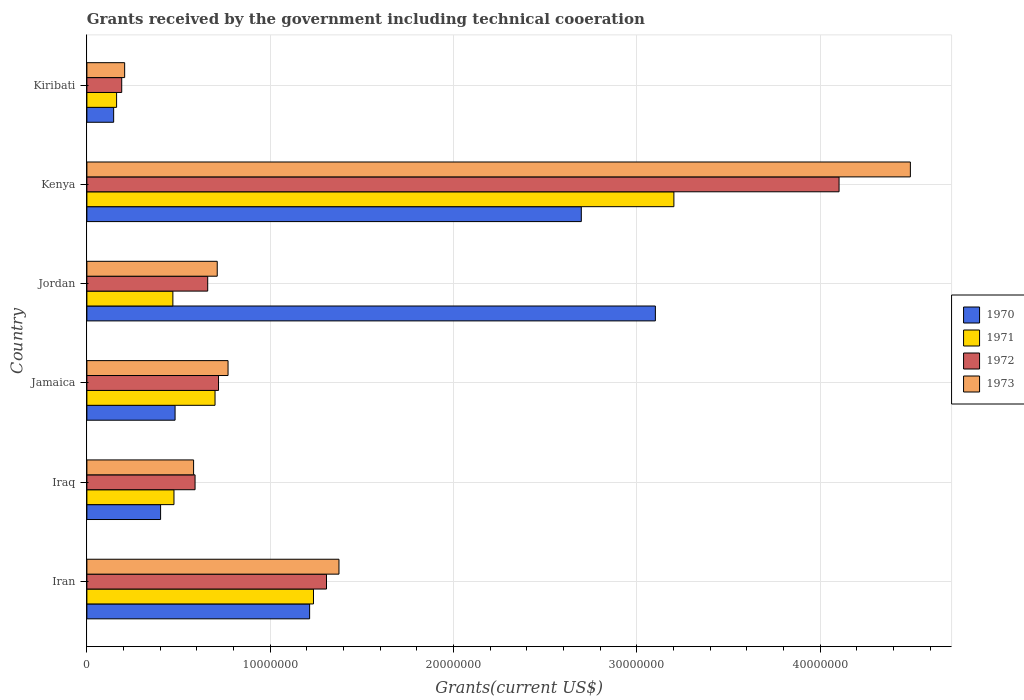How many bars are there on the 2nd tick from the top?
Offer a terse response. 4. How many bars are there on the 5th tick from the bottom?
Provide a short and direct response. 4. What is the label of the 2nd group of bars from the top?
Your answer should be compact. Kenya. What is the total grants received by the government in 1971 in Kiribati?
Your answer should be compact. 1.62e+06. Across all countries, what is the maximum total grants received by the government in 1972?
Your answer should be very brief. 4.10e+07. Across all countries, what is the minimum total grants received by the government in 1971?
Provide a succinct answer. 1.62e+06. In which country was the total grants received by the government in 1971 maximum?
Offer a very short reply. Kenya. In which country was the total grants received by the government in 1973 minimum?
Provide a short and direct response. Kiribati. What is the total total grants received by the government in 1971 in the graph?
Your answer should be very brief. 6.24e+07. What is the difference between the total grants received by the government in 1972 in Iran and that in Iraq?
Offer a very short reply. 7.17e+06. What is the difference between the total grants received by the government in 1972 in Jamaica and the total grants received by the government in 1973 in Kenya?
Ensure brevity in your answer.  -3.77e+07. What is the average total grants received by the government in 1970 per country?
Keep it short and to the point. 1.34e+07. What is the difference between the total grants received by the government in 1970 and total grants received by the government in 1973 in Iraq?
Provide a short and direct response. -1.80e+06. What is the ratio of the total grants received by the government in 1972 in Iran to that in Kiribati?
Keep it short and to the point. 6.88. Is the total grants received by the government in 1973 in Jamaica less than that in Kenya?
Give a very brief answer. Yes. What is the difference between the highest and the second highest total grants received by the government in 1971?
Your answer should be compact. 1.97e+07. What is the difference between the highest and the lowest total grants received by the government in 1971?
Ensure brevity in your answer.  3.04e+07. In how many countries, is the total grants received by the government in 1970 greater than the average total grants received by the government in 1970 taken over all countries?
Your answer should be compact. 2. Is the sum of the total grants received by the government in 1972 in Kenya and Kiribati greater than the maximum total grants received by the government in 1971 across all countries?
Ensure brevity in your answer.  Yes. What does the 4th bar from the top in Jamaica represents?
Your answer should be compact. 1970. What does the 2nd bar from the bottom in Kenya represents?
Your response must be concise. 1971. Is it the case that in every country, the sum of the total grants received by the government in 1971 and total grants received by the government in 1970 is greater than the total grants received by the government in 1972?
Give a very brief answer. Yes. How many countries are there in the graph?
Ensure brevity in your answer.  6. What is the difference between two consecutive major ticks on the X-axis?
Provide a succinct answer. 1.00e+07. Are the values on the major ticks of X-axis written in scientific E-notation?
Make the answer very short. No. Does the graph contain grids?
Your response must be concise. Yes. How many legend labels are there?
Keep it short and to the point. 4. How are the legend labels stacked?
Give a very brief answer. Vertical. What is the title of the graph?
Ensure brevity in your answer.  Grants received by the government including technical cooeration. What is the label or title of the X-axis?
Make the answer very short. Grants(current US$). What is the Grants(current US$) in 1970 in Iran?
Offer a terse response. 1.22e+07. What is the Grants(current US$) of 1971 in Iran?
Provide a short and direct response. 1.24e+07. What is the Grants(current US$) in 1972 in Iran?
Provide a succinct answer. 1.31e+07. What is the Grants(current US$) of 1973 in Iran?
Make the answer very short. 1.38e+07. What is the Grants(current US$) of 1970 in Iraq?
Your answer should be very brief. 4.02e+06. What is the Grants(current US$) of 1971 in Iraq?
Provide a short and direct response. 4.75e+06. What is the Grants(current US$) in 1972 in Iraq?
Offer a very short reply. 5.90e+06. What is the Grants(current US$) in 1973 in Iraq?
Offer a terse response. 5.82e+06. What is the Grants(current US$) of 1970 in Jamaica?
Offer a very short reply. 4.81e+06. What is the Grants(current US$) of 1971 in Jamaica?
Ensure brevity in your answer.  6.99e+06. What is the Grants(current US$) of 1972 in Jamaica?
Offer a very short reply. 7.18e+06. What is the Grants(current US$) in 1973 in Jamaica?
Keep it short and to the point. 7.70e+06. What is the Grants(current US$) in 1970 in Jordan?
Ensure brevity in your answer.  3.10e+07. What is the Grants(current US$) in 1971 in Jordan?
Offer a very short reply. 4.69e+06. What is the Grants(current US$) of 1972 in Jordan?
Keep it short and to the point. 6.59e+06. What is the Grants(current US$) in 1973 in Jordan?
Ensure brevity in your answer.  7.11e+06. What is the Grants(current US$) of 1970 in Kenya?
Provide a succinct answer. 2.70e+07. What is the Grants(current US$) of 1971 in Kenya?
Your answer should be very brief. 3.20e+07. What is the Grants(current US$) of 1972 in Kenya?
Provide a short and direct response. 4.10e+07. What is the Grants(current US$) in 1973 in Kenya?
Your answer should be very brief. 4.49e+07. What is the Grants(current US$) in 1970 in Kiribati?
Your answer should be compact. 1.46e+06. What is the Grants(current US$) of 1971 in Kiribati?
Make the answer very short. 1.62e+06. What is the Grants(current US$) of 1972 in Kiribati?
Provide a succinct answer. 1.90e+06. What is the Grants(current US$) in 1973 in Kiribati?
Your response must be concise. 2.06e+06. Across all countries, what is the maximum Grants(current US$) in 1970?
Your answer should be compact. 3.10e+07. Across all countries, what is the maximum Grants(current US$) of 1971?
Provide a short and direct response. 3.20e+07. Across all countries, what is the maximum Grants(current US$) in 1972?
Provide a succinct answer. 4.10e+07. Across all countries, what is the maximum Grants(current US$) of 1973?
Your answer should be very brief. 4.49e+07. Across all countries, what is the minimum Grants(current US$) of 1970?
Your answer should be compact. 1.46e+06. Across all countries, what is the minimum Grants(current US$) of 1971?
Ensure brevity in your answer.  1.62e+06. Across all countries, what is the minimum Grants(current US$) of 1972?
Give a very brief answer. 1.90e+06. Across all countries, what is the minimum Grants(current US$) of 1973?
Give a very brief answer. 2.06e+06. What is the total Grants(current US$) in 1970 in the graph?
Your response must be concise. 8.04e+07. What is the total Grants(current US$) of 1971 in the graph?
Your answer should be very brief. 6.24e+07. What is the total Grants(current US$) of 1972 in the graph?
Keep it short and to the point. 7.57e+07. What is the total Grants(current US$) of 1973 in the graph?
Provide a succinct answer. 8.14e+07. What is the difference between the Grants(current US$) in 1970 in Iran and that in Iraq?
Your response must be concise. 8.13e+06. What is the difference between the Grants(current US$) in 1971 in Iran and that in Iraq?
Make the answer very short. 7.61e+06. What is the difference between the Grants(current US$) in 1972 in Iran and that in Iraq?
Offer a very short reply. 7.17e+06. What is the difference between the Grants(current US$) in 1973 in Iran and that in Iraq?
Offer a very short reply. 7.93e+06. What is the difference between the Grants(current US$) of 1970 in Iran and that in Jamaica?
Ensure brevity in your answer.  7.34e+06. What is the difference between the Grants(current US$) in 1971 in Iran and that in Jamaica?
Ensure brevity in your answer.  5.37e+06. What is the difference between the Grants(current US$) of 1972 in Iran and that in Jamaica?
Ensure brevity in your answer.  5.89e+06. What is the difference between the Grants(current US$) in 1973 in Iran and that in Jamaica?
Your answer should be very brief. 6.05e+06. What is the difference between the Grants(current US$) of 1970 in Iran and that in Jordan?
Offer a very short reply. -1.89e+07. What is the difference between the Grants(current US$) of 1971 in Iran and that in Jordan?
Offer a very short reply. 7.67e+06. What is the difference between the Grants(current US$) of 1972 in Iran and that in Jordan?
Provide a short and direct response. 6.48e+06. What is the difference between the Grants(current US$) in 1973 in Iran and that in Jordan?
Give a very brief answer. 6.64e+06. What is the difference between the Grants(current US$) of 1970 in Iran and that in Kenya?
Provide a succinct answer. -1.48e+07. What is the difference between the Grants(current US$) in 1971 in Iran and that in Kenya?
Your answer should be compact. -1.97e+07. What is the difference between the Grants(current US$) in 1972 in Iran and that in Kenya?
Provide a short and direct response. -2.80e+07. What is the difference between the Grants(current US$) of 1973 in Iran and that in Kenya?
Make the answer very short. -3.12e+07. What is the difference between the Grants(current US$) of 1970 in Iran and that in Kiribati?
Keep it short and to the point. 1.07e+07. What is the difference between the Grants(current US$) of 1971 in Iran and that in Kiribati?
Offer a very short reply. 1.07e+07. What is the difference between the Grants(current US$) of 1972 in Iran and that in Kiribati?
Provide a succinct answer. 1.12e+07. What is the difference between the Grants(current US$) in 1973 in Iran and that in Kiribati?
Keep it short and to the point. 1.17e+07. What is the difference between the Grants(current US$) of 1970 in Iraq and that in Jamaica?
Keep it short and to the point. -7.90e+05. What is the difference between the Grants(current US$) in 1971 in Iraq and that in Jamaica?
Provide a short and direct response. -2.24e+06. What is the difference between the Grants(current US$) of 1972 in Iraq and that in Jamaica?
Your answer should be very brief. -1.28e+06. What is the difference between the Grants(current US$) in 1973 in Iraq and that in Jamaica?
Provide a short and direct response. -1.88e+06. What is the difference between the Grants(current US$) of 1970 in Iraq and that in Jordan?
Your response must be concise. -2.70e+07. What is the difference between the Grants(current US$) in 1972 in Iraq and that in Jordan?
Your answer should be compact. -6.90e+05. What is the difference between the Grants(current US$) in 1973 in Iraq and that in Jordan?
Your answer should be compact. -1.29e+06. What is the difference between the Grants(current US$) of 1970 in Iraq and that in Kenya?
Your response must be concise. -2.30e+07. What is the difference between the Grants(current US$) in 1971 in Iraq and that in Kenya?
Provide a succinct answer. -2.73e+07. What is the difference between the Grants(current US$) in 1972 in Iraq and that in Kenya?
Provide a succinct answer. -3.51e+07. What is the difference between the Grants(current US$) of 1973 in Iraq and that in Kenya?
Provide a succinct answer. -3.91e+07. What is the difference between the Grants(current US$) in 1970 in Iraq and that in Kiribati?
Give a very brief answer. 2.56e+06. What is the difference between the Grants(current US$) of 1971 in Iraq and that in Kiribati?
Ensure brevity in your answer.  3.13e+06. What is the difference between the Grants(current US$) of 1972 in Iraq and that in Kiribati?
Your response must be concise. 4.00e+06. What is the difference between the Grants(current US$) of 1973 in Iraq and that in Kiribati?
Keep it short and to the point. 3.76e+06. What is the difference between the Grants(current US$) in 1970 in Jamaica and that in Jordan?
Keep it short and to the point. -2.62e+07. What is the difference between the Grants(current US$) in 1971 in Jamaica and that in Jordan?
Make the answer very short. 2.30e+06. What is the difference between the Grants(current US$) of 1972 in Jamaica and that in Jordan?
Give a very brief answer. 5.90e+05. What is the difference between the Grants(current US$) in 1973 in Jamaica and that in Jordan?
Ensure brevity in your answer.  5.90e+05. What is the difference between the Grants(current US$) in 1970 in Jamaica and that in Kenya?
Keep it short and to the point. -2.22e+07. What is the difference between the Grants(current US$) of 1971 in Jamaica and that in Kenya?
Make the answer very short. -2.50e+07. What is the difference between the Grants(current US$) of 1972 in Jamaica and that in Kenya?
Your answer should be compact. -3.38e+07. What is the difference between the Grants(current US$) of 1973 in Jamaica and that in Kenya?
Provide a short and direct response. -3.72e+07. What is the difference between the Grants(current US$) of 1970 in Jamaica and that in Kiribati?
Your response must be concise. 3.35e+06. What is the difference between the Grants(current US$) of 1971 in Jamaica and that in Kiribati?
Offer a very short reply. 5.37e+06. What is the difference between the Grants(current US$) of 1972 in Jamaica and that in Kiribati?
Your answer should be compact. 5.28e+06. What is the difference between the Grants(current US$) in 1973 in Jamaica and that in Kiribati?
Provide a succinct answer. 5.64e+06. What is the difference between the Grants(current US$) in 1970 in Jordan and that in Kenya?
Offer a terse response. 4.04e+06. What is the difference between the Grants(current US$) of 1971 in Jordan and that in Kenya?
Offer a terse response. -2.73e+07. What is the difference between the Grants(current US$) of 1972 in Jordan and that in Kenya?
Give a very brief answer. -3.44e+07. What is the difference between the Grants(current US$) of 1973 in Jordan and that in Kenya?
Offer a terse response. -3.78e+07. What is the difference between the Grants(current US$) in 1970 in Jordan and that in Kiribati?
Your answer should be compact. 2.96e+07. What is the difference between the Grants(current US$) in 1971 in Jordan and that in Kiribati?
Keep it short and to the point. 3.07e+06. What is the difference between the Grants(current US$) in 1972 in Jordan and that in Kiribati?
Give a very brief answer. 4.69e+06. What is the difference between the Grants(current US$) in 1973 in Jordan and that in Kiribati?
Provide a succinct answer. 5.05e+06. What is the difference between the Grants(current US$) of 1970 in Kenya and that in Kiribati?
Your answer should be very brief. 2.55e+07. What is the difference between the Grants(current US$) of 1971 in Kenya and that in Kiribati?
Offer a very short reply. 3.04e+07. What is the difference between the Grants(current US$) in 1972 in Kenya and that in Kiribati?
Provide a short and direct response. 3.91e+07. What is the difference between the Grants(current US$) in 1973 in Kenya and that in Kiribati?
Ensure brevity in your answer.  4.29e+07. What is the difference between the Grants(current US$) in 1970 in Iran and the Grants(current US$) in 1971 in Iraq?
Give a very brief answer. 7.40e+06. What is the difference between the Grants(current US$) of 1970 in Iran and the Grants(current US$) of 1972 in Iraq?
Offer a terse response. 6.25e+06. What is the difference between the Grants(current US$) of 1970 in Iran and the Grants(current US$) of 1973 in Iraq?
Provide a short and direct response. 6.33e+06. What is the difference between the Grants(current US$) of 1971 in Iran and the Grants(current US$) of 1972 in Iraq?
Provide a succinct answer. 6.46e+06. What is the difference between the Grants(current US$) in 1971 in Iran and the Grants(current US$) in 1973 in Iraq?
Give a very brief answer. 6.54e+06. What is the difference between the Grants(current US$) in 1972 in Iran and the Grants(current US$) in 1973 in Iraq?
Your response must be concise. 7.25e+06. What is the difference between the Grants(current US$) in 1970 in Iran and the Grants(current US$) in 1971 in Jamaica?
Make the answer very short. 5.16e+06. What is the difference between the Grants(current US$) in 1970 in Iran and the Grants(current US$) in 1972 in Jamaica?
Offer a terse response. 4.97e+06. What is the difference between the Grants(current US$) of 1970 in Iran and the Grants(current US$) of 1973 in Jamaica?
Your answer should be compact. 4.45e+06. What is the difference between the Grants(current US$) of 1971 in Iran and the Grants(current US$) of 1972 in Jamaica?
Offer a very short reply. 5.18e+06. What is the difference between the Grants(current US$) in 1971 in Iran and the Grants(current US$) in 1973 in Jamaica?
Your answer should be very brief. 4.66e+06. What is the difference between the Grants(current US$) of 1972 in Iran and the Grants(current US$) of 1973 in Jamaica?
Provide a short and direct response. 5.37e+06. What is the difference between the Grants(current US$) of 1970 in Iran and the Grants(current US$) of 1971 in Jordan?
Ensure brevity in your answer.  7.46e+06. What is the difference between the Grants(current US$) in 1970 in Iran and the Grants(current US$) in 1972 in Jordan?
Keep it short and to the point. 5.56e+06. What is the difference between the Grants(current US$) in 1970 in Iran and the Grants(current US$) in 1973 in Jordan?
Make the answer very short. 5.04e+06. What is the difference between the Grants(current US$) in 1971 in Iran and the Grants(current US$) in 1972 in Jordan?
Keep it short and to the point. 5.77e+06. What is the difference between the Grants(current US$) of 1971 in Iran and the Grants(current US$) of 1973 in Jordan?
Ensure brevity in your answer.  5.25e+06. What is the difference between the Grants(current US$) of 1972 in Iran and the Grants(current US$) of 1973 in Jordan?
Ensure brevity in your answer.  5.96e+06. What is the difference between the Grants(current US$) in 1970 in Iran and the Grants(current US$) in 1971 in Kenya?
Make the answer very short. -1.99e+07. What is the difference between the Grants(current US$) in 1970 in Iran and the Grants(current US$) in 1972 in Kenya?
Give a very brief answer. -2.89e+07. What is the difference between the Grants(current US$) in 1970 in Iran and the Grants(current US$) in 1973 in Kenya?
Offer a very short reply. -3.28e+07. What is the difference between the Grants(current US$) of 1971 in Iran and the Grants(current US$) of 1972 in Kenya?
Keep it short and to the point. -2.87e+07. What is the difference between the Grants(current US$) in 1971 in Iran and the Grants(current US$) in 1973 in Kenya?
Your response must be concise. -3.26e+07. What is the difference between the Grants(current US$) of 1972 in Iran and the Grants(current US$) of 1973 in Kenya?
Provide a short and direct response. -3.18e+07. What is the difference between the Grants(current US$) in 1970 in Iran and the Grants(current US$) in 1971 in Kiribati?
Give a very brief answer. 1.05e+07. What is the difference between the Grants(current US$) of 1970 in Iran and the Grants(current US$) of 1972 in Kiribati?
Offer a very short reply. 1.02e+07. What is the difference between the Grants(current US$) in 1970 in Iran and the Grants(current US$) in 1973 in Kiribati?
Provide a short and direct response. 1.01e+07. What is the difference between the Grants(current US$) of 1971 in Iran and the Grants(current US$) of 1972 in Kiribati?
Your response must be concise. 1.05e+07. What is the difference between the Grants(current US$) of 1971 in Iran and the Grants(current US$) of 1973 in Kiribati?
Give a very brief answer. 1.03e+07. What is the difference between the Grants(current US$) of 1972 in Iran and the Grants(current US$) of 1973 in Kiribati?
Give a very brief answer. 1.10e+07. What is the difference between the Grants(current US$) of 1970 in Iraq and the Grants(current US$) of 1971 in Jamaica?
Provide a short and direct response. -2.97e+06. What is the difference between the Grants(current US$) of 1970 in Iraq and the Grants(current US$) of 1972 in Jamaica?
Make the answer very short. -3.16e+06. What is the difference between the Grants(current US$) in 1970 in Iraq and the Grants(current US$) in 1973 in Jamaica?
Offer a terse response. -3.68e+06. What is the difference between the Grants(current US$) in 1971 in Iraq and the Grants(current US$) in 1972 in Jamaica?
Offer a terse response. -2.43e+06. What is the difference between the Grants(current US$) in 1971 in Iraq and the Grants(current US$) in 1973 in Jamaica?
Make the answer very short. -2.95e+06. What is the difference between the Grants(current US$) of 1972 in Iraq and the Grants(current US$) of 1973 in Jamaica?
Your answer should be very brief. -1.80e+06. What is the difference between the Grants(current US$) of 1970 in Iraq and the Grants(current US$) of 1971 in Jordan?
Make the answer very short. -6.70e+05. What is the difference between the Grants(current US$) of 1970 in Iraq and the Grants(current US$) of 1972 in Jordan?
Your answer should be compact. -2.57e+06. What is the difference between the Grants(current US$) in 1970 in Iraq and the Grants(current US$) in 1973 in Jordan?
Ensure brevity in your answer.  -3.09e+06. What is the difference between the Grants(current US$) in 1971 in Iraq and the Grants(current US$) in 1972 in Jordan?
Offer a terse response. -1.84e+06. What is the difference between the Grants(current US$) of 1971 in Iraq and the Grants(current US$) of 1973 in Jordan?
Ensure brevity in your answer.  -2.36e+06. What is the difference between the Grants(current US$) of 1972 in Iraq and the Grants(current US$) of 1973 in Jordan?
Keep it short and to the point. -1.21e+06. What is the difference between the Grants(current US$) in 1970 in Iraq and the Grants(current US$) in 1971 in Kenya?
Provide a short and direct response. -2.80e+07. What is the difference between the Grants(current US$) of 1970 in Iraq and the Grants(current US$) of 1972 in Kenya?
Ensure brevity in your answer.  -3.70e+07. What is the difference between the Grants(current US$) of 1970 in Iraq and the Grants(current US$) of 1973 in Kenya?
Give a very brief answer. -4.09e+07. What is the difference between the Grants(current US$) of 1971 in Iraq and the Grants(current US$) of 1972 in Kenya?
Your response must be concise. -3.63e+07. What is the difference between the Grants(current US$) in 1971 in Iraq and the Grants(current US$) in 1973 in Kenya?
Ensure brevity in your answer.  -4.02e+07. What is the difference between the Grants(current US$) of 1972 in Iraq and the Grants(current US$) of 1973 in Kenya?
Make the answer very short. -3.90e+07. What is the difference between the Grants(current US$) of 1970 in Iraq and the Grants(current US$) of 1971 in Kiribati?
Keep it short and to the point. 2.40e+06. What is the difference between the Grants(current US$) of 1970 in Iraq and the Grants(current US$) of 1972 in Kiribati?
Provide a short and direct response. 2.12e+06. What is the difference between the Grants(current US$) of 1970 in Iraq and the Grants(current US$) of 1973 in Kiribati?
Ensure brevity in your answer.  1.96e+06. What is the difference between the Grants(current US$) of 1971 in Iraq and the Grants(current US$) of 1972 in Kiribati?
Make the answer very short. 2.85e+06. What is the difference between the Grants(current US$) of 1971 in Iraq and the Grants(current US$) of 1973 in Kiribati?
Provide a short and direct response. 2.69e+06. What is the difference between the Grants(current US$) in 1972 in Iraq and the Grants(current US$) in 1973 in Kiribati?
Your answer should be compact. 3.84e+06. What is the difference between the Grants(current US$) in 1970 in Jamaica and the Grants(current US$) in 1972 in Jordan?
Your response must be concise. -1.78e+06. What is the difference between the Grants(current US$) in 1970 in Jamaica and the Grants(current US$) in 1973 in Jordan?
Provide a short and direct response. -2.30e+06. What is the difference between the Grants(current US$) in 1971 in Jamaica and the Grants(current US$) in 1972 in Jordan?
Your answer should be very brief. 4.00e+05. What is the difference between the Grants(current US$) of 1970 in Jamaica and the Grants(current US$) of 1971 in Kenya?
Your answer should be compact. -2.72e+07. What is the difference between the Grants(current US$) in 1970 in Jamaica and the Grants(current US$) in 1972 in Kenya?
Your answer should be compact. -3.62e+07. What is the difference between the Grants(current US$) in 1970 in Jamaica and the Grants(current US$) in 1973 in Kenya?
Offer a very short reply. -4.01e+07. What is the difference between the Grants(current US$) of 1971 in Jamaica and the Grants(current US$) of 1972 in Kenya?
Your answer should be compact. -3.40e+07. What is the difference between the Grants(current US$) of 1971 in Jamaica and the Grants(current US$) of 1973 in Kenya?
Offer a very short reply. -3.79e+07. What is the difference between the Grants(current US$) in 1972 in Jamaica and the Grants(current US$) in 1973 in Kenya?
Your answer should be very brief. -3.77e+07. What is the difference between the Grants(current US$) of 1970 in Jamaica and the Grants(current US$) of 1971 in Kiribati?
Provide a short and direct response. 3.19e+06. What is the difference between the Grants(current US$) of 1970 in Jamaica and the Grants(current US$) of 1972 in Kiribati?
Ensure brevity in your answer.  2.91e+06. What is the difference between the Grants(current US$) in 1970 in Jamaica and the Grants(current US$) in 1973 in Kiribati?
Provide a short and direct response. 2.75e+06. What is the difference between the Grants(current US$) in 1971 in Jamaica and the Grants(current US$) in 1972 in Kiribati?
Provide a short and direct response. 5.09e+06. What is the difference between the Grants(current US$) of 1971 in Jamaica and the Grants(current US$) of 1973 in Kiribati?
Your response must be concise. 4.93e+06. What is the difference between the Grants(current US$) of 1972 in Jamaica and the Grants(current US$) of 1973 in Kiribati?
Keep it short and to the point. 5.12e+06. What is the difference between the Grants(current US$) of 1970 in Jordan and the Grants(current US$) of 1971 in Kenya?
Give a very brief answer. -1.01e+06. What is the difference between the Grants(current US$) of 1970 in Jordan and the Grants(current US$) of 1972 in Kenya?
Offer a terse response. -1.00e+07. What is the difference between the Grants(current US$) of 1970 in Jordan and the Grants(current US$) of 1973 in Kenya?
Your answer should be very brief. -1.39e+07. What is the difference between the Grants(current US$) of 1971 in Jordan and the Grants(current US$) of 1972 in Kenya?
Offer a very short reply. -3.63e+07. What is the difference between the Grants(current US$) in 1971 in Jordan and the Grants(current US$) in 1973 in Kenya?
Provide a succinct answer. -4.02e+07. What is the difference between the Grants(current US$) in 1972 in Jordan and the Grants(current US$) in 1973 in Kenya?
Give a very brief answer. -3.83e+07. What is the difference between the Grants(current US$) of 1970 in Jordan and the Grants(current US$) of 1971 in Kiribati?
Your response must be concise. 2.94e+07. What is the difference between the Grants(current US$) in 1970 in Jordan and the Grants(current US$) in 1972 in Kiribati?
Offer a very short reply. 2.91e+07. What is the difference between the Grants(current US$) of 1970 in Jordan and the Grants(current US$) of 1973 in Kiribati?
Provide a succinct answer. 2.90e+07. What is the difference between the Grants(current US$) in 1971 in Jordan and the Grants(current US$) in 1972 in Kiribati?
Your answer should be very brief. 2.79e+06. What is the difference between the Grants(current US$) of 1971 in Jordan and the Grants(current US$) of 1973 in Kiribati?
Offer a terse response. 2.63e+06. What is the difference between the Grants(current US$) in 1972 in Jordan and the Grants(current US$) in 1973 in Kiribati?
Your answer should be very brief. 4.53e+06. What is the difference between the Grants(current US$) in 1970 in Kenya and the Grants(current US$) in 1971 in Kiribati?
Keep it short and to the point. 2.54e+07. What is the difference between the Grants(current US$) of 1970 in Kenya and the Grants(current US$) of 1972 in Kiribati?
Provide a short and direct response. 2.51e+07. What is the difference between the Grants(current US$) of 1970 in Kenya and the Grants(current US$) of 1973 in Kiribati?
Your answer should be compact. 2.49e+07. What is the difference between the Grants(current US$) in 1971 in Kenya and the Grants(current US$) in 1972 in Kiribati?
Keep it short and to the point. 3.01e+07. What is the difference between the Grants(current US$) in 1971 in Kenya and the Grants(current US$) in 1973 in Kiribati?
Provide a succinct answer. 3.00e+07. What is the difference between the Grants(current US$) of 1972 in Kenya and the Grants(current US$) of 1973 in Kiribati?
Offer a terse response. 3.90e+07. What is the average Grants(current US$) in 1970 per country?
Offer a terse response. 1.34e+07. What is the average Grants(current US$) in 1971 per country?
Offer a very short reply. 1.04e+07. What is the average Grants(current US$) in 1972 per country?
Make the answer very short. 1.26e+07. What is the average Grants(current US$) in 1973 per country?
Give a very brief answer. 1.36e+07. What is the difference between the Grants(current US$) in 1970 and Grants(current US$) in 1971 in Iran?
Your answer should be very brief. -2.10e+05. What is the difference between the Grants(current US$) of 1970 and Grants(current US$) of 1972 in Iran?
Provide a short and direct response. -9.20e+05. What is the difference between the Grants(current US$) in 1970 and Grants(current US$) in 1973 in Iran?
Your response must be concise. -1.60e+06. What is the difference between the Grants(current US$) in 1971 and Grants(current US$) in 1972 in Iran?
Offer a terse response. -7.10e+05. What is the difference between the Grants(current US$) in 1971 and Grants(current US$) in 1973 in Iran?
Keep it short and to the point. -1.39e+06. What is the difference between the Grants(current US$) of 1972 and Grants(current US$) of 1973 in Iran?
Provide a short and direct response. -6.80e+05. What is the difference between the Grants(current US$) of 1970 and Grants(current US$) of 1971 in Iraq?
Keep it short and to the point. -7.30e+05. What is the difference between the Grants(current US$) of 1970 and Grants(current US$) of 1972 in Iraq?
Make the answer very short. -1.88e+06. What is the difference between the Grants(current US$) of 1970 and Grants(current US$) of 1973 in Iraq?
Keep it short and to the point. -1.80e+06. What is the difference between the Grants(current US$) of 1971 and Grants(current US$) of 1972 in Iraq?
Offer a very short reply. -1.15e+06. What is the difference between the Grants(current US$) of 1971 and Grants(current US$) of 1973 in Iraq?
Provide a short and direct response. -1.07e+06. What is the difference between the Grants(current US$) in 1972 and Grants(current US$) in 1973 in Iraq?
Make the answer very short. 8.00e+04. What is the difference between the Grants(current US$) in 1970 and Grants(current US$) in 1971 in Jamaica?
Your answer should be very brief. -2.18e+06. What is the difference between the Grants(current US$) of 1970 and Grants(current US$) of 1972 in Jamaica?
Ensure brevity in your answer.  -2.37e+06. What is the difference between the Grants(current US$) in 1970 and Grants(current US$) in 1973 in Jamaica?
Give a very brief answer. -2.89e+06. What is the difference between the Grants(current US$) in 1971 and Grants(current US$) in 1973 in Jamaica?
Your answer should be compact. -7.10e+05. What is the difference between the Grants(current US$) of 1972 and Grants(current US$) of 1973 in Jamaica?
Ensure brevity in your answer.  -5.20e+05. What is the difference between the Grants(current US$) in 1970 and Grants(current US$) in 1971 in Jordan?
Keep it short and to the point. 2.63e+07. What is the difference between the Grants(current US$) in 1970 and Grants(current US$) in 1972 in Jordan?
Make the answer very short. 2.44e+07. What is the difference between the Grants(current US$) in 1970 and Grants(current US$) in 1973 in Jordan?
Make the answer very short. 2.39e+07. What is the difference between the Grants(current US$) in 1971 and Grants(current US$) in 1972 in Jordan?
Make the answer very short. -1.90e+06. What is the difference between the Grants(current US$) in 1971 and Grants(current US$) in 1973 in Jordan?
Keep it short and to the point. -2.42e+06. What is the difference between the Grants(current US$) in 1972 and Grants(current US$) in 1973 in Jordan?
Your answer should be compact. -5.20e+05. What is the difference between the Grants(current US$) in 1970 and Grants(current US$) in 1971 in Kenya?
Your answer should be very brief. -5.05e+06. What is the difference between the Grants(current US$) of 1970 and Grants(current US$) of 1972 in Kenya?
Provide a succinct answer. -1.41e+07. What is the difference between the Grants(current US$) of 1970 and Grants(current US$) of 1973 in Kenya?
Offer a terse response. -1.80e+07. What is the difference between the Grants(current US$) in 1971 and Grants(current US$) in 1972 in Kenya?
Provide a short and direct response. -9.01e+06. What is the difference between the Grants(current US$) in 1971 and Grants(current US$) in 1973 in Kenya?
Keep it short and to the point. -1.29e+07. What is the difference between the Grants(current US$) of 1972 and Grants(current US$) of 1973 in Kenya?
Keep it short and to the point. -3.89e+06. What is the difference between the Grants(current US$) of 1970 and Grants(current US$) of 1971 in Kiribati?
Offer a very short reply. -1.60e+05. What is the difference between the Grants(current US$) in 1970 and Grants(current US$) in 1972 in Kiribati?
Provide a short and direct response. -4.40e+05. What is the difference between the Grants(current US$) in 1970 and Grants(current US$) in 1973 in Kiribati?
Your response must be concise. -6.00e+05. What is the difference between the Grants(current US$) of 1971 and Grants(current US$) of 1972 in Kiribati?
Your answer should be very brief. -2.80e+05. What is the difference between the Grants(current US$) of 1971 and Grants(current US$) of 1973 in Kiribati?
Give a very brief answer. -4.40e+05. What is the difference between the Grants(current US$) in 1972 and Grants(current US$) in 1973 in Kiribati?
Ensure brevity in your answer.  -1.60e+05. What is the ratio of the Grants(current US$) of 1970 in Iran to that in Iraq?
Offer a very short reply. 3.02. What is the ratio of the Grants(current US$) of 1971 in Iran to that in Iraq?
Your answer should be very brief. 2.6. What is the ratio of the Grants(current US$) of 1972 in Iran to that in Iraq?
Keep it short and to the point. 2.22. What is the ratio of the Grants(current US$) in 1973 in Iran to that in Iraq?
Offer a terse response. 2.36. What is the ratio of the Grants(current US$) of 1970 in Iran to that in Jamaica?
Give a very brief answer. 2.53. What is the ratio of the Grants(current US$) of 1971 in Iran to that in Jamaica?
Your answer should be very brief. 1.77. What is the ratio of the Grants(current US$) of 1972 in Iran to that in Jamaica?
Ensure brevity in your answer.  1.82. What is the ratio of the Grants(current US$) of 1973 in Iran to that in Jamaica?
Provide a short and direct response. 1.79. What is the ratio of the Grants(current US$) of 1970 in Iran to that in Jordan?
Offer a very short reply. 0.39. What is the ratio of the Grants(current US$) of 1971 in Iran to that in Jordan?
Ensure brevity in your answer.  2.64. What is the ratio of the Grants(current US$) in 1972 in Iran to that in Jordan?
Offer a terse response. 1.98. What is the ratio of the Grants(current US$) of 1973 in Iran to that in Jordan?
Provide a short and direct response. 1.93. What is the ratio of the Grants(current US$) in 1970 in Iran to that in Kenya?
Offer a very short reply. 0.45. What is the ratio of the Grants(current US$) in 1971 in Iran to that in Kenya?
Make the answer very short. 0.39. What is the ratio of the Grants(current US$) of 1972 in Iran to that in Kenya?
Offer a terse response. 0.32. What is the ratio of the Grants(current US$) in 1973 in Iran to that in Kenya?
Your answer should be very brief. 0.31. What is the ratio of the Grants(current US$) of 1970 in Iran to that in Kiribati?
Give a very brief answer. 8.32. What is the ratio of the Grants(current US$) of 1971 in Iran to that in Kiribati?
Provide a short and direct response. 7.63. What is the ratio of the Grants(current US$) in 1972 in Iran to that in Kiribati?
Ensure brevity in your answer.  6.88. What is the ratio of the Grants(current US$) in 1973 in Iran to that in Kiribati?
Keep it short and to the point. 6.67. What is the ratio of the Grants(current US$) in 1970 in Iraq to that in Jamaica?
Offer a terse response. 0.84. What is the ratio of the Grants(current US$) of 1971 in Iraq to that in Jamaica?
Ensure brevity in your answer.  0.68. What is the ratio of the Grants(current US$) in 1972 in Iraq to that in Jamaica?
Your response must be concise. 0.82. What is the ratio of the Grants(current US$) of 1973 in Iraq to that in Jamaica?
Offer a very short reply. 0.76. What is the ratio of the Grants(current US$) of 1970 in Iraq to that in Jordan?
Provide a short and direct response. 0.13. What is the ratio of the Grants(current US$) of 1971 in Iraq to that in Jordan?
Your response must be concise. 1.01. What is the ratio of the Grants(current US$) in 1972 in Iraq to that in Jordan?
Ensure brevity in your answer.  0.9. What is the ratio of the Grants(current US$) in 1973 in Iraq to that in Jordan?
Offer a terse response. 0.82. What is the ratio of the Grants(current US$) in 1970 in Iraq to that in Kenya?
Offer a terse response. 0.15. What is the ratio of the Grants(current US$) in 1971 in Iraq to that in Kenya?
Make the answer very short. 0.15. What is the ratio of the Grants(current US$) in 1972 in Iraq to that in Kenya?
Provide a succinct answer. 0.14. What is the ratio of the Grants(current US$) of 1973 in Iraq to that in Kenya?
Make the answer very short. 0.13. What is the ratio of the Grants(current US$) in 1970 in Iraq to that in Kiribati?
Ensure brevity in your answer.  2.75. What is the ratio of the Grants(current US$) in 1971 in Iraq to that in Kiribati?
Provide a short and direct response. 2.93. What is the ratio of the Grants(current US$) in 1972 in Iraq to that in Kiribati?
Make the answer very short. 3.11. What is the ratio of the Grants(current US$) of 1973 in Iraq to that in Kiribati?
Make the answer very short. 2.83. What is the ratio of the Grants(current US$) of 1970 in Jamaica to that in Jordan?
Offer a terse response. 0.16. What is the ratio of the Grants(current US$) of 1971 in Jamaica to that in Jordan?
Ensure brevity in your answer.  1.49. What is the ratio of the Grants(current US$) of 1972 in Jamaica to that in Jordan?
Provide a short and direct response. 1.09. What is the ratio of the Grants(current US$) in 1973 in Jamaica to that in Jordan?
Your answer should be very brief. 1.08. What is the ratio of the Grants(current US$) of 1970 in Jamaica to that in Kenya?
Make the answer very short. 0.18. What is the ratio of the Grants(current US$) in 1971 in Jamaica to that in Kenya?
Offer a terse response. 0.22. What is the ratio of the Grants(current US$) of 1972 in Jamaica to that in Kenya?
Provide a succinct answer. 0.17. What is the ratio of the Grants(current US$) in 1973 in Jamaica to that in Kenya?
Offer a very short reply. 0.17. What is the ratio of the Grants(current US$) in 1970 in Jamaica to that in Kiribati?
Offer a very short reply. 3.29. What is the ratio of the Grants(current US$) of 1971 in Jamaica to that in Kiribati?
Your answer should be very brief. 4.31. What is the ratio of the Grants(current US$) of 1972 in Jamaica to that in Kiribati?
Make the answer very short. 3.78. What is the ratio of the Grants(current US$) in 1973 in Jamaica to that in Kiribati?
Keep it short and to the point. 3.74. What is the ratio of the Grants(current US$) of 1970 in Jordan to that in Kenya?
Make the answer very short. 1.15. What is the ratio of the Grants(current US$) in 1971 in Jordan to that in Kenya?
Offer a terse response. 0.15. What is the ratio of the Grants(current US$) of 1972 in Jordan to that in Kenya?
Provide a succinct answer. 0.16. What is the ratio of the Grants(current US$) in 1973 in Jordan to that in Kenya?
Your response must be concise. 0.16. What is the ratio of the Grants(current US$) in 1970 in Jordan to that in Kiribati?
Offer a very short reply. 21.24. What is the ratio of the Grants(current US$) in 1971 in Jordan to that in Kiribati?
Provide a short and direct response. 2.9. What is the ratio of the Grants(current US$) of 1972 in Jordan to that in Kiribati?
Provide a short and direct response. 3.47. What is the ratio of the Grants(current US$) of 1973 in Jordan to that in Kiribati?
Your answer should be compact. 3.45. What is the ratio of the Grants(current US$) in 1970 in Kenya to that in Kiribati?
Your answer should be very brief. 18.47. What is the ratio of the Grants(current US$) of 1971 in Kenya to that in Kiribati?
Offer a very short reply. 19.77. What is the ratio of the Grants(current US$) in 1972 in Kenya to that in Kiribati?
Your answer should be very brief. 21.59. What is the ratio of the Grants(current US$) of 1973 in Kenya to that in Kiribati?
Offer a very short reply. 21.81. What is the difference between the highest and the second highest Grants(current US$) in 1970?
Your answer should be very brief. 4.04e+06. What is the difference between the highest and the second highest Grants(current US$) of 1971?
Provide a succinct answer. 1.97e+07. What is the difference between the highest and the second highest Grants(current US$) in 1972?
Provide a short and direct response. 2.80e+07. What is the difference between the highest and the second highest Grants(current US$) of 1973?
Offer a very short reply. 3.12e+07. What is the difference between the highest and the lowest Grants(current US$) in 1970?
Give a very brief answer. 2.96e+07. What is the difference between the highest and the lowest Grants(current US$) in 1971?
Keep it short and to the point. 3.04e+07. What is the difference between the highest and the lowest Grants(current US$) in 1972?
Offer a very short reply. 3.91e+07. What is the difference between the highest and the lowest Grants(current US$) in 1973?
Your response must be concise. 4.29e+07. 